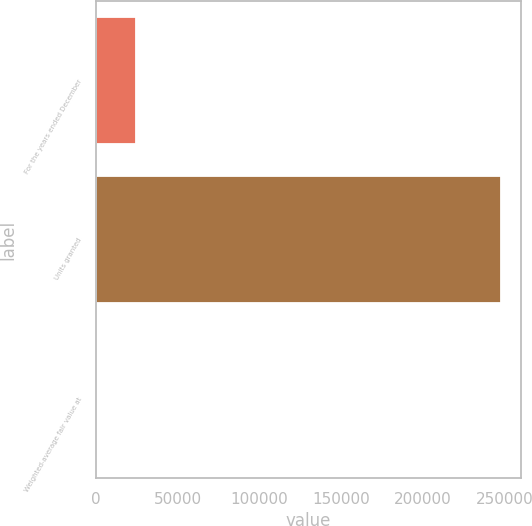<chart> <loc_0><loc_0><loc_500><loc_500><bar_chart><fcel>For the years ended December<fcel>Units granted<fcel>Weighted-average fair value at<nl><fcel>24783.7<fcel>247340<fcel>55.24<nl></chart> 